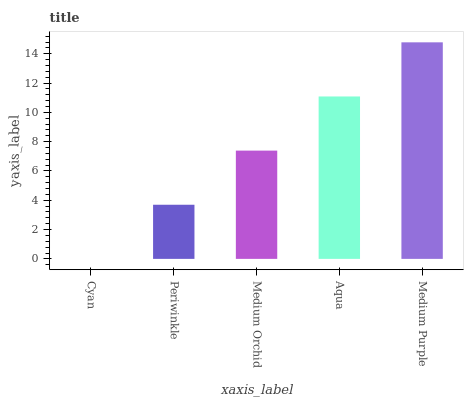Is Cyan the minimum?
Answer yes or no. Yes. Is Medium Purple the maximum?
Answer yes or no. Yes. Is Periwinkle the minimum?
Answer yes or no. No. Is Periwinkle the maximum?
Answer yes or no. No. Is Periwinkle greater than Cyan?
Answer yes or no. Yes. Is Cyan less than Periwinkle?
Answer yes or no. Yes. Is Cyan greater than Periwinkle?
Answer yes or no. No. Is Periwinkle less than Cyan?
Answer yes or no. No. Is Medium Orchid the high median?
Answer yes or no. Yes. Is Medium Orchid the low median?
Answer yes or no. Yes. Is Periwinkle the high median?
Answer yes or no. No. Is Medium Purple the low median?
Answer yes or no. No. 